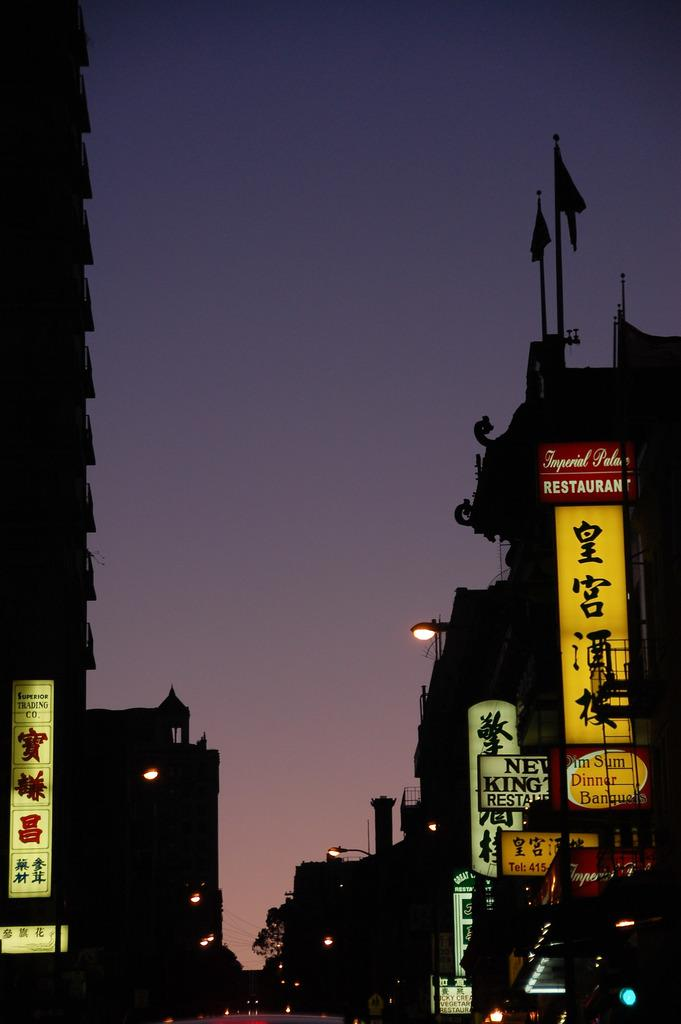<image>
Summarize the visual content of the image. The name of the store to the left is called Superior Trading Co 